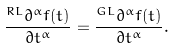Convert formula to latex. <formula><loc_0><loc_0><loc_500><loc_500>\frac { ^ { R L } \partial ^ { \alpha } f ( t ) } { \partial t ^ { \alpha } } = \frac { ^ { G L } \partial ^ { \alpha } f ( t ) } { \partial t ^ { \alpha } } .</formula> 